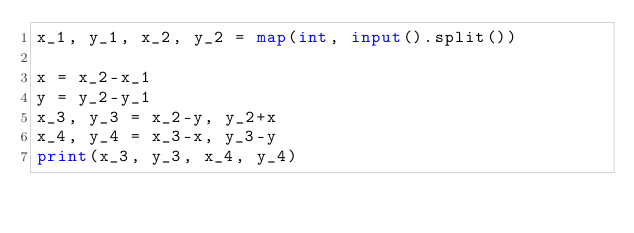Convert code to text. <code><loc_0><loc_0><loc_500><loc_500><_Python_>x_1, y_1, x_2, y_2 = map(int, input().split())

x = x_2-x_1
y = y_2-y_1
x_3, y_3 = x_2-y, y_2+x
x_4, y_4 = x_3-x, y_3-y
print(x_3, y_3, x_4, y_4)</code> 